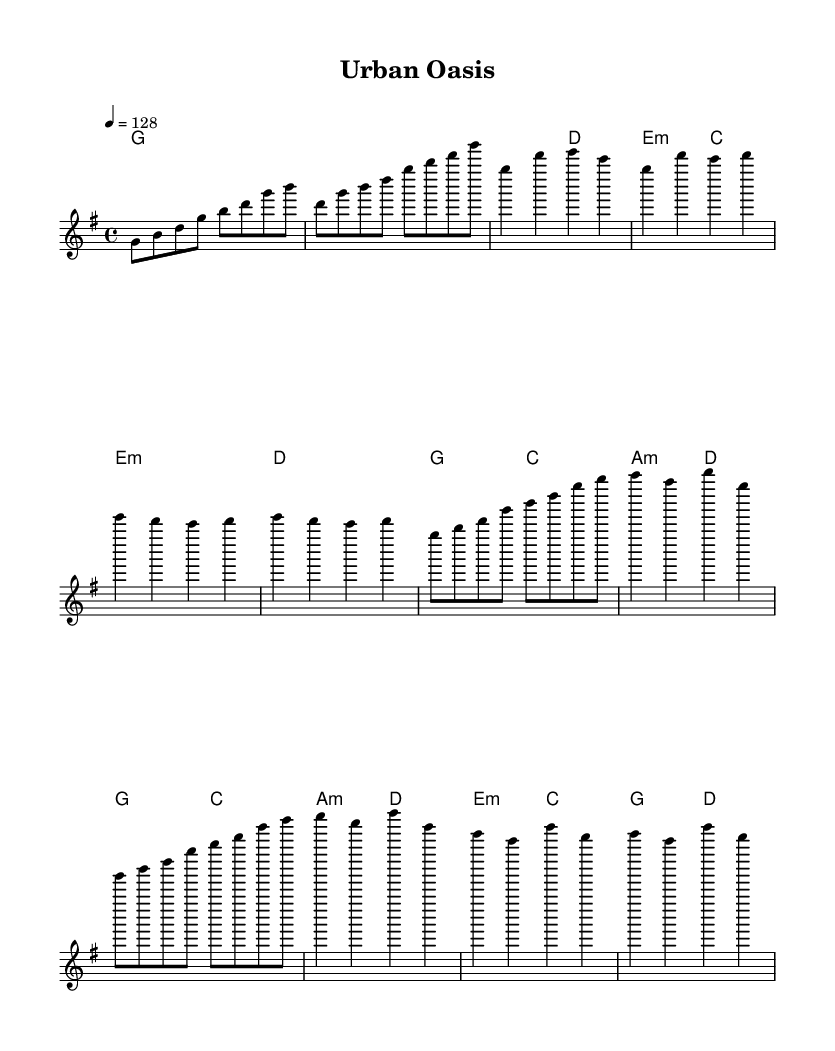What is the key signature of this music? The key signature is G major, which has one sharp (F#). This can be identified by looking at the key signature part of the sheet music, where the F# is indicated.
Answer: G major What is the time signature of this piece? The time signature is 4/4, which indicates there are four beats in each measure and a quarter note receives one beat. This is visually represented at the beginning of the score.
Answer: 4/4 What is the tempo marking for the piece? The tempo marking is 128 beats per minute, indicated by the notation tempo 4 = 128. This tells performers to play at a brisk pace.
Answer: 128 How many measures are there in the chorus? There are 4 measures in the chorus, as evidenced by counting the number of grouped sets of notes under the chorus section labeled in the music.
Answer: 4 What is the first chord in the piece? The first chord is G major, as noted in the chord names section at the start of the score. It is indicated by the "g" label before the first measure.
Answer: G major What does the structural layout (verse, pre-chorus, chorus) indicate about the song? The structure shows a common K-pop format with a clear build-up from the verse to the pre-chorus leading into a catchy chorus which is characteristic of upbeat K-pop tracks. Each section contributes to creating a dynamic flow that captivates the listener.
Answer: Verse, Pre-Chorus, Chorus 